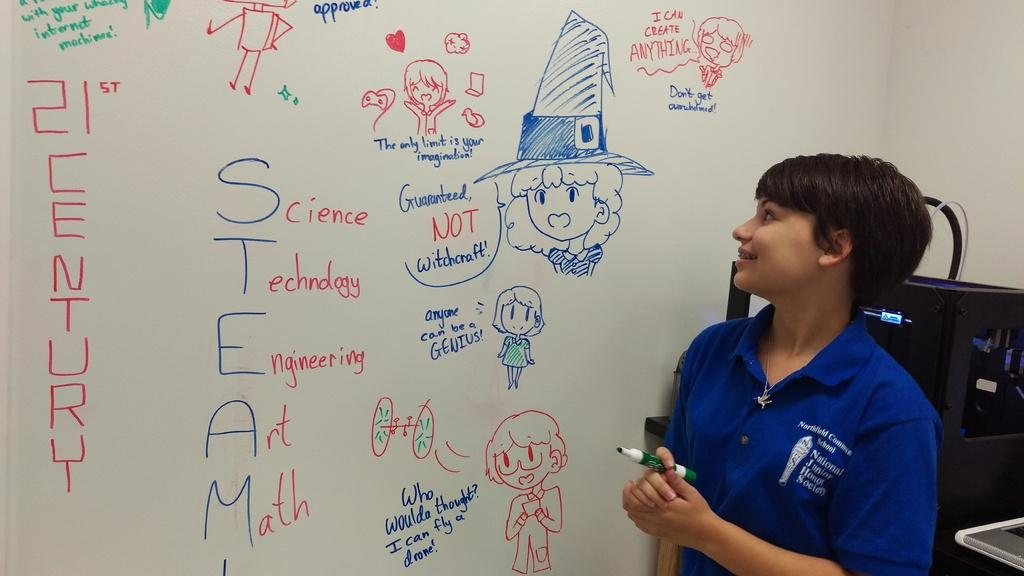<image>
Give a short and clear explanation of the subsequent image. Someone stands at a whiteboard with the word STEAM on it. 